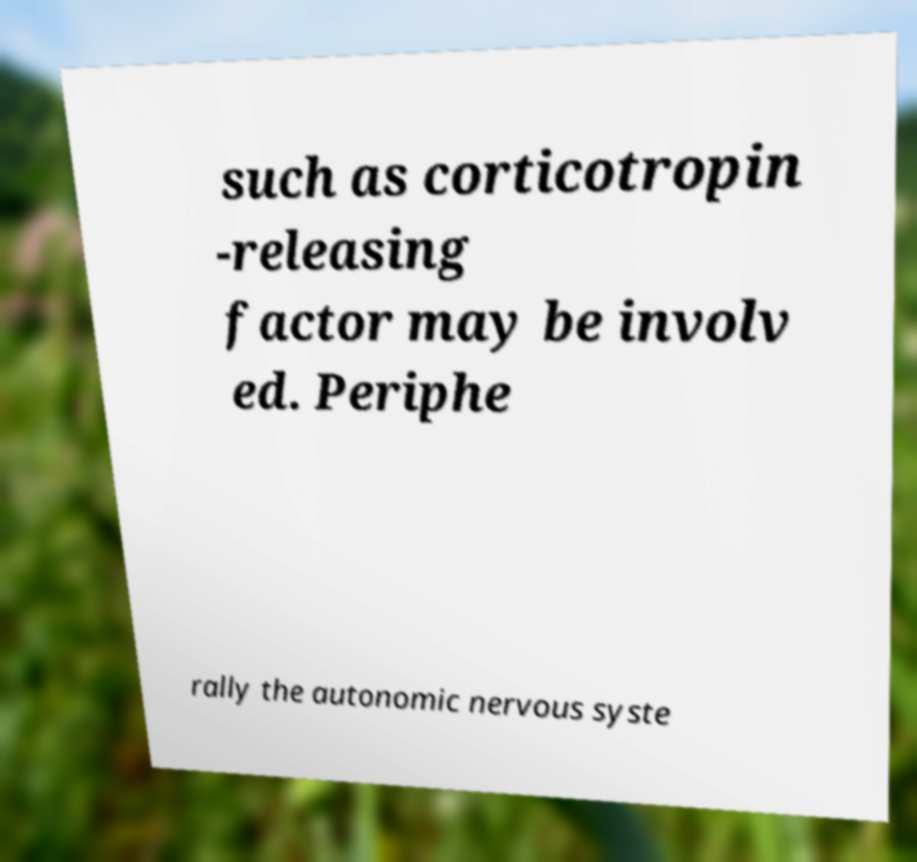Could you extract and type out the text from this image? such as corticotropin -releasing factor may be involv ed. Periphe rally the autonomic nervous syste 